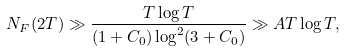Convert formula to latex. <formula><loc_0><loc_0><loc_500><loc_500>N _ { F } ( 2 T ) \gg \frac { T \log T } { ( 1 + C _ { 0 } ) \log ^ { 2 } ( 3 + C _ { 0 } ) } \gg A T \log T ,</formula> 